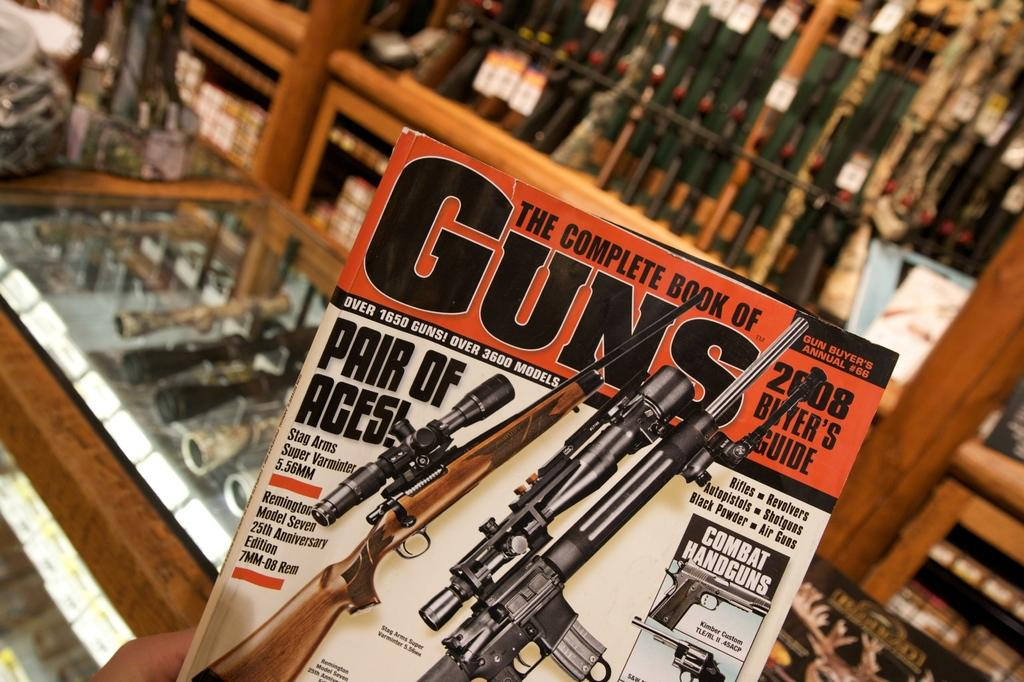<image>
Give a short and clear explanation of the subsequent image. A gun magazine advertises over 1650 guns and over 3600 models. 